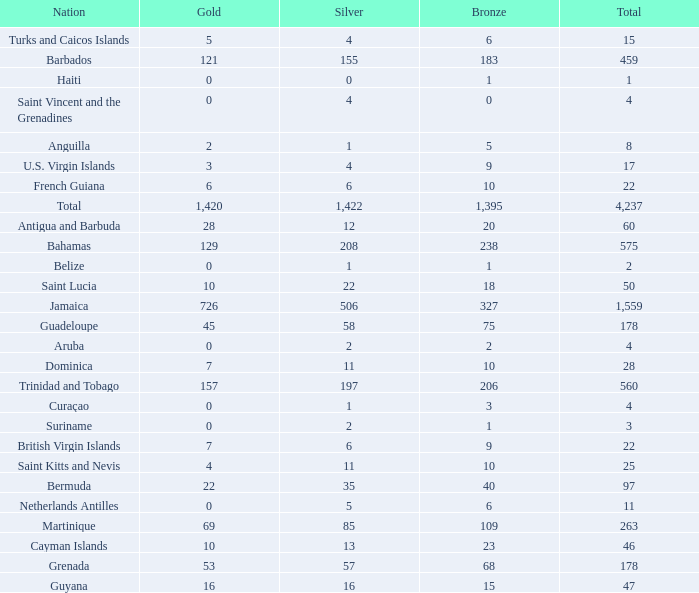What's the sum of Gold with a Bronze that's larger than 15, Silver that's smaller than 197, the Nation of Saint Lucia, and has a Total that is larger than 50? None. Could you parse the entire table? {'header': ['Nation', 'Gold', 'Silver', 'Bronze', 'Total'], 'rows': [['Turks and Caicos Islands', '5', '4', '6', '15'], ['Barbados', '121', '155', '183', '459'], ['Haiti', '0', '0', '1', '1'], ['Saint Vincent and the Grenadines', '0', '4', '0', '4'], ['Anguilla', '2', '1', '5', '8'], ['U.S. Virgin Islands', '3', '4', '9', '17'], ['French Guiana', '6', '6', '10', '22'], ['Total', '1,420', '1,422', '1,395', '4,237'], ['Antigua and Barbuda', '28', '12', '20', '60'], ['Bahamas', '129', '208', '238', '575'], ['Belize', '0', '1', '1', '2'], ['Saint Lucia', '10', '22', '18', '50'], ['Jamaica', '726', '506', '327', '1,559'], ['Guadeloupe', '45', '58', '75', '178'], ['Aruba', '0', '2', '2', '4'], ['Dominica', '7', '11', '10', '28'], ['Trinidad and Tobago', '157', '197', '206', '560'], ['Curaçao', '0', '1', '3', '4'], ['Suriname', '0', '2', '1', '3'], ['British Virgin Islands', '7', '6', '9', '22'], ['Saint Kitts and Nevis', '4', '11', '10', '25'], ['Bermuda', '22', '35', '40', '97'], ['Netherlands Antilles', '0', '5', '6', '11'], ['Martinique', '69', '85', '109', '263'], ['Cayman Islands', '10', '13', '23', '46'], ['Grenada', '53', '57', '68', '178'], ['Guyana', '16', '16', '15', '47']]} 